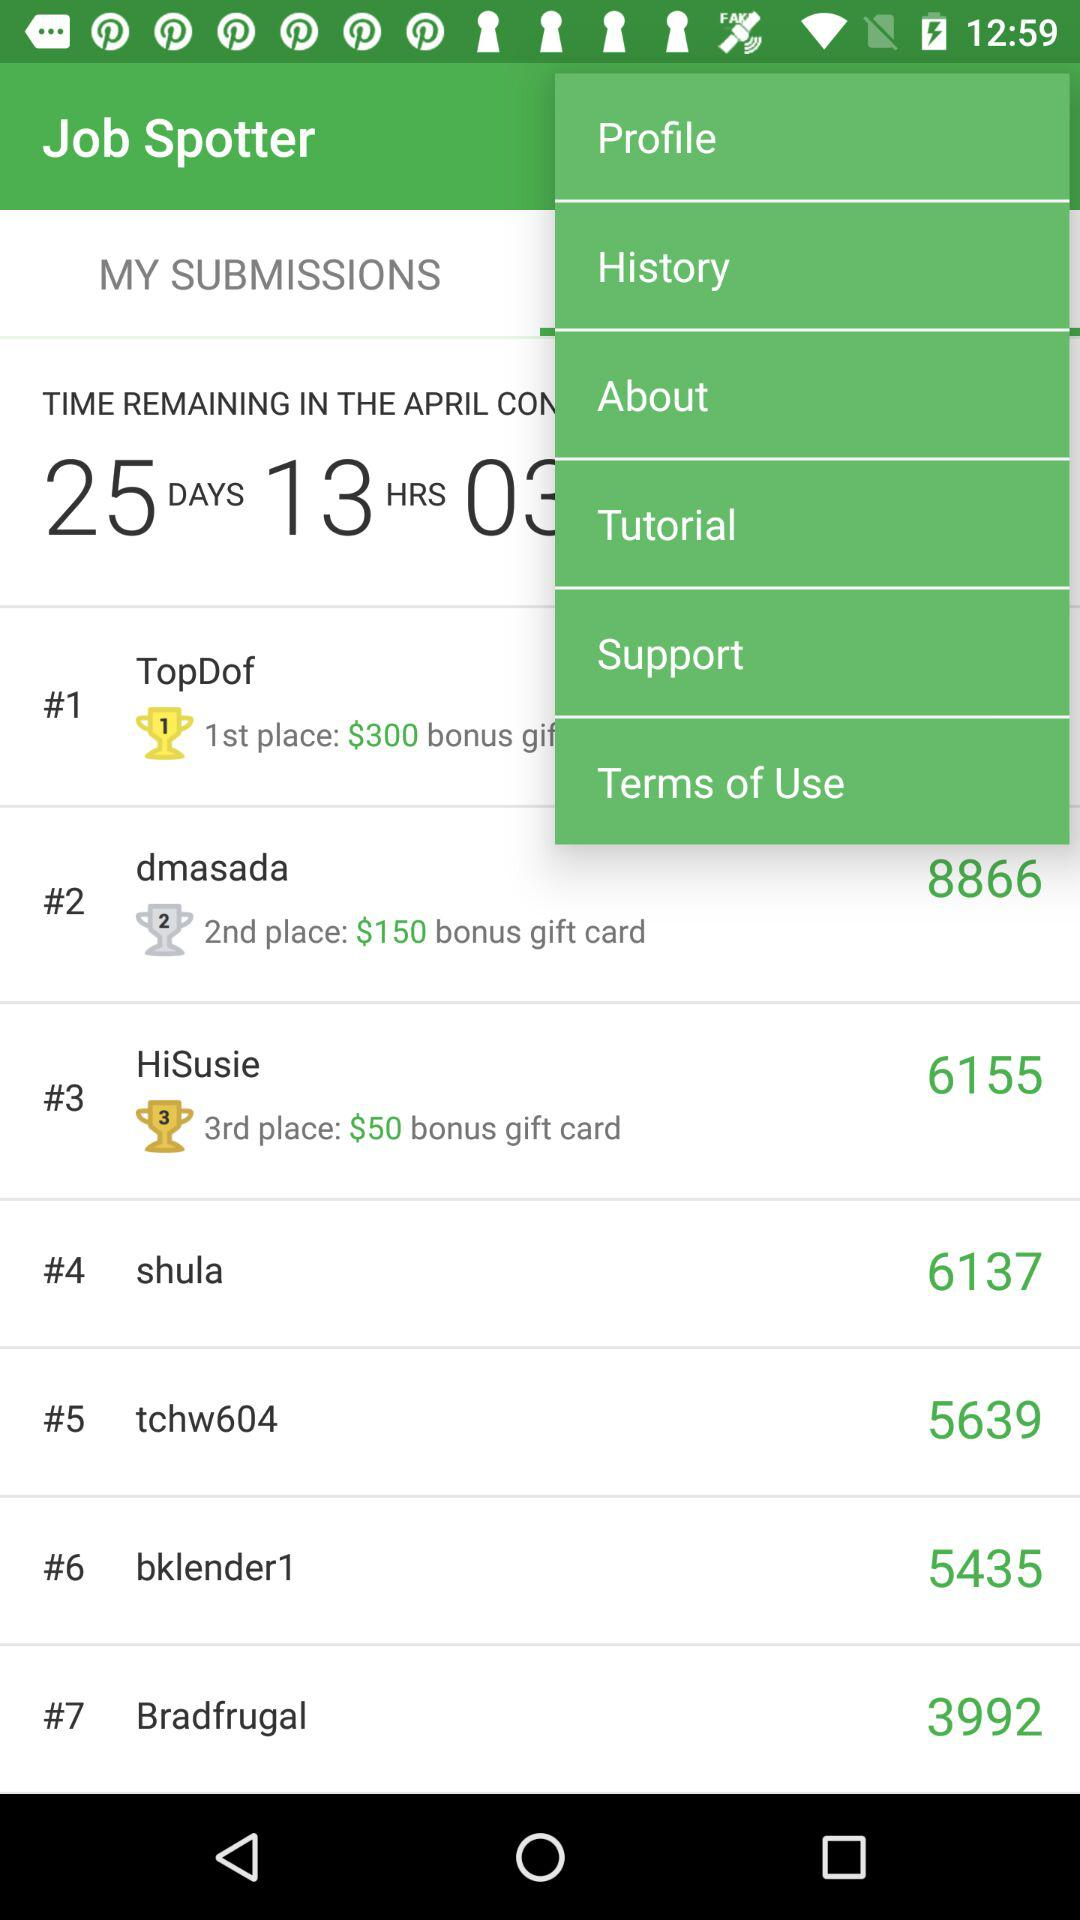How many notifications are there in "History"?
When the provided information is insufficient, respond with <no answer>. <no answer> 